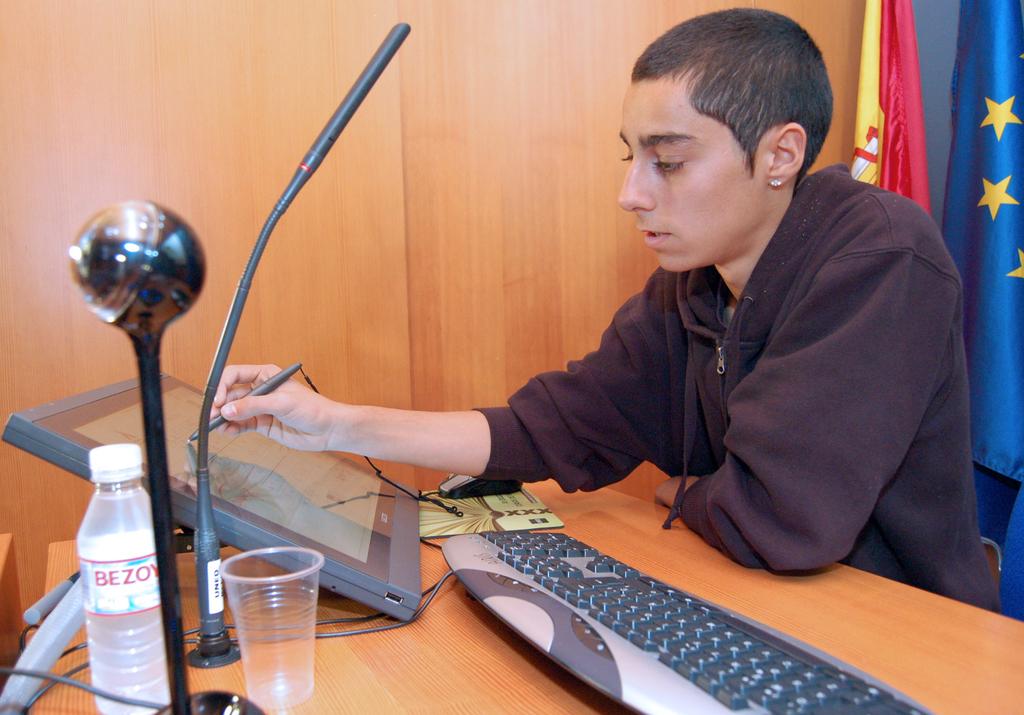What brand is the bottle of water?
Ensure brevity in your answer.  Bezov. 